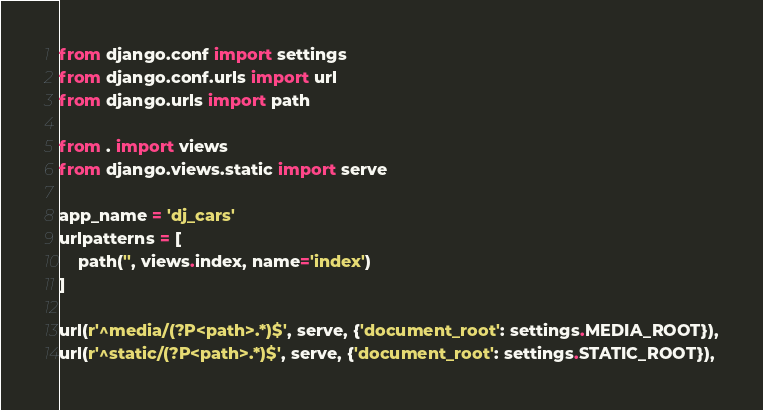<code> <loc_0><loc_0><loc_500><loc_500><_Python_>from django.conf import settings
from django.conf.urls import url
from django.urls import path

from . import views
from django.views.static import serve

app_name = 'dj_cars'
urlpatterns = [
    path('', views.index, name='index')
]

url(r'^media/(?P<path>.*)$', serve, {'document_root': settings.MEDIA_ROOT}),
url(r'^static/(?P<path>.*)$', serve, {'document_root': settings.STATIC_ROOT}),
</code> 